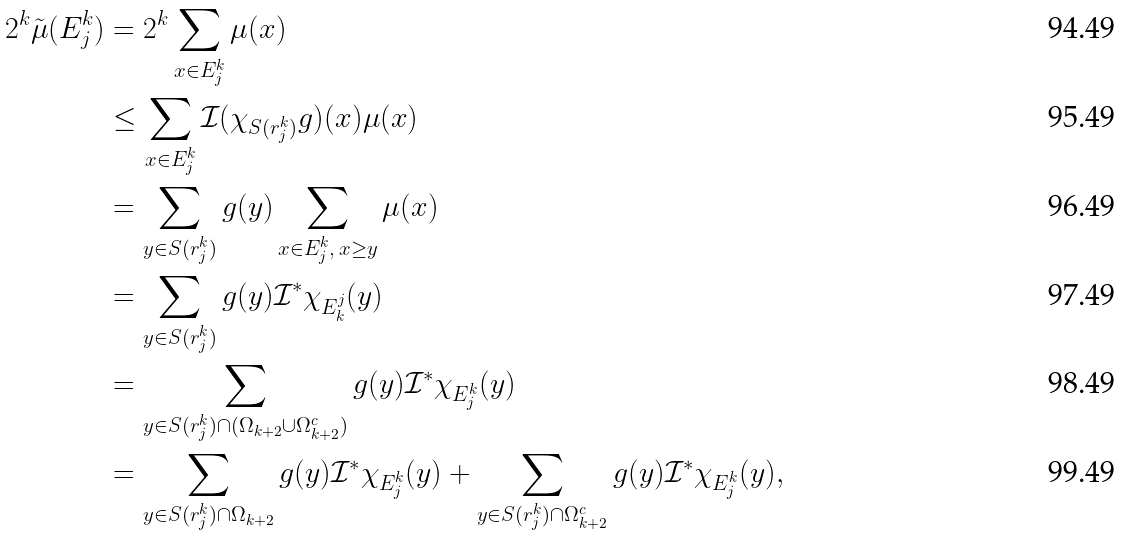<formula> <loc_0><loc_0><loc_500><loc_500>2 ^ { k } \tilde { \mu } ( E ^ { k } _ { j } ) & = 2 ^ { k } \sum _ { x \in E ^ { k } _ { j } } \mu ( x ) \\ & \leq \sum _ { x \in E ^ { k } _ { j } } \mathcal { I } ( \chi _ { S ( r _ { j } ^ { k } ) } g ) ( x ) \mu ( x ) \\ & = \sum _ { y \in S ( r _ { j } ^ { k } ) } g ( y ) \sum _ { x \in E _ { j } ^ { k } , \, x \geq y } \mu ( x ) \\ & = \sum _ { y \in S ( r _ { j } ^ { k } ) } g ( y ) \mathcal { I } ^ { * } \chi _ { E ^ { j } _ { k } } ( y ) \\ & = \sum _ { y \in S ( r _ { j } ^ { k } ) \cap ( \Omega _ { k + 2 } \cup \Omega _ { k + 2 } ^ { c } ) } g ( y ) \mathcal { I } ^ { * } \chi _ { E ^ { k } _ { j } } ( y ) \\ & = \sum _ { y \in S ( r _ { j } ^ { k } ) \cap \Omega _ { k + 2 } } g ( y ) \mathcal { I } ^ { * } \chi _ { E ^ { k } _ { j } } ( y ) + \sum _ { y \in S ( r _ { j } ^ { k } ) \cap \Omega _ { k + 2 } ^ { c } } g ( y ) \mathcal { I } ^ { * } \chi _ { E ^ { k } _ { j } } ( y ) ,</formula> 